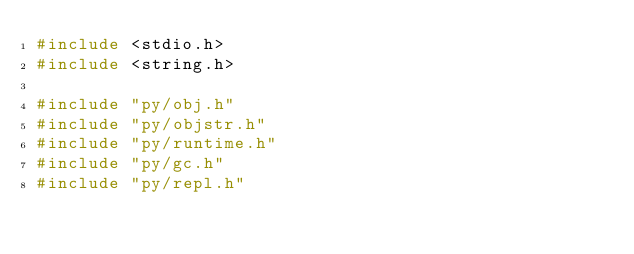<code> <loc_0><loc_0><loc_500><loc_500><_C_>#include <stdio.h>
#include <string.h>

#include "py/obj.h"
#include "py/objstr.h"
#include "py/runtime.h"
#include "py/gc.h"
#include "py/repl.h"</code> 